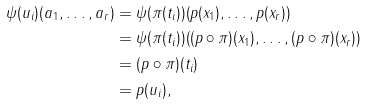Convert formula to latex. <formula><loc_0><loc_0><loc_500><loc_500>\psi ( u _ { i } ) ( a _ { 1 } , \dots , a _ { r } ) & = \psi ( \pi ( t _ { i } ) ) ( p ( x _ { 1 } ) , \dots , p ( x _ { r } ) ) \\ & = \psi ( \pi ( t _ { i } ) ) ( ( p \circ \pi ) ( x _ { 1 } ) , \dots , ( p \circ \pi ) ( x _ { r } ) ) \\ & = ( p \circ \pi ) ( t _ { i } ) \\ & = p ( u _ { i } ) ,</formula> 